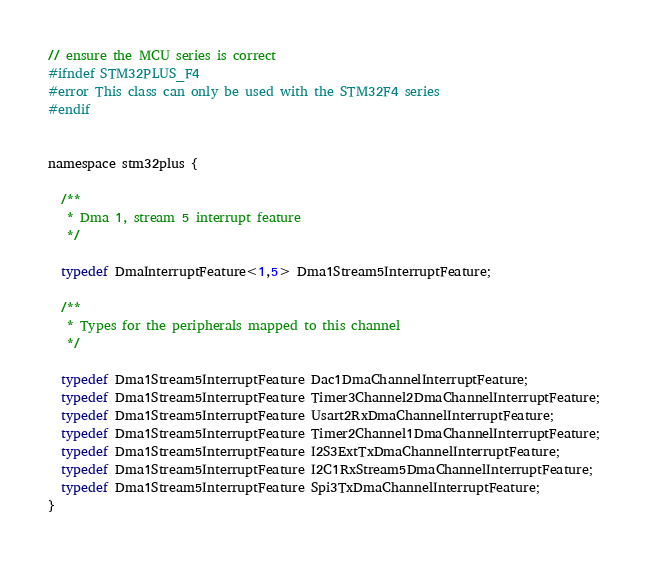Convert code to text. <code><loc_0><loc_0><loc_500><loc_500><_C_>
// ensure the MCU series is correct
#ifndef STM32PLUS_F4
#error This class can only be used with the STM32F4 series
#endif


namespace stm32plus {

  /**
   * Dma 1, stream 5 interrupt feature
   */

  typedef DmaInterruptFeature<1,5> Dma1Stream5InterruptFeature;

  /**
   * Types for the peripherals mapped to this channel
   */

  typedef Dma1Stream5InterruptFeature Dac1DmaChannelInterruptFeature;
  typedef Dma1Stream5InterruptFeature Timer3Channel2DmaChannelInterruptFeature;
  typedef Dma1Stream5InterruptFeature Usart2RxDmaChannelInterruptFeature;
  typedef Dma1Stream5InterruptFeature Timer2Channel1DmaChannelInterruptFeature;
  typedef Dma1Stream5InterruptFeature I2S3ExtTxDmaChannelInterruptFeature;
  typedef Dma1Stream5InterruptFeature I2C1RxStream5DmaChannelInterruptFeature;
  typedef Dma1Stream5InterruptFeature Spi3TxDmaChannelInterruptFeature;
}
</code> 